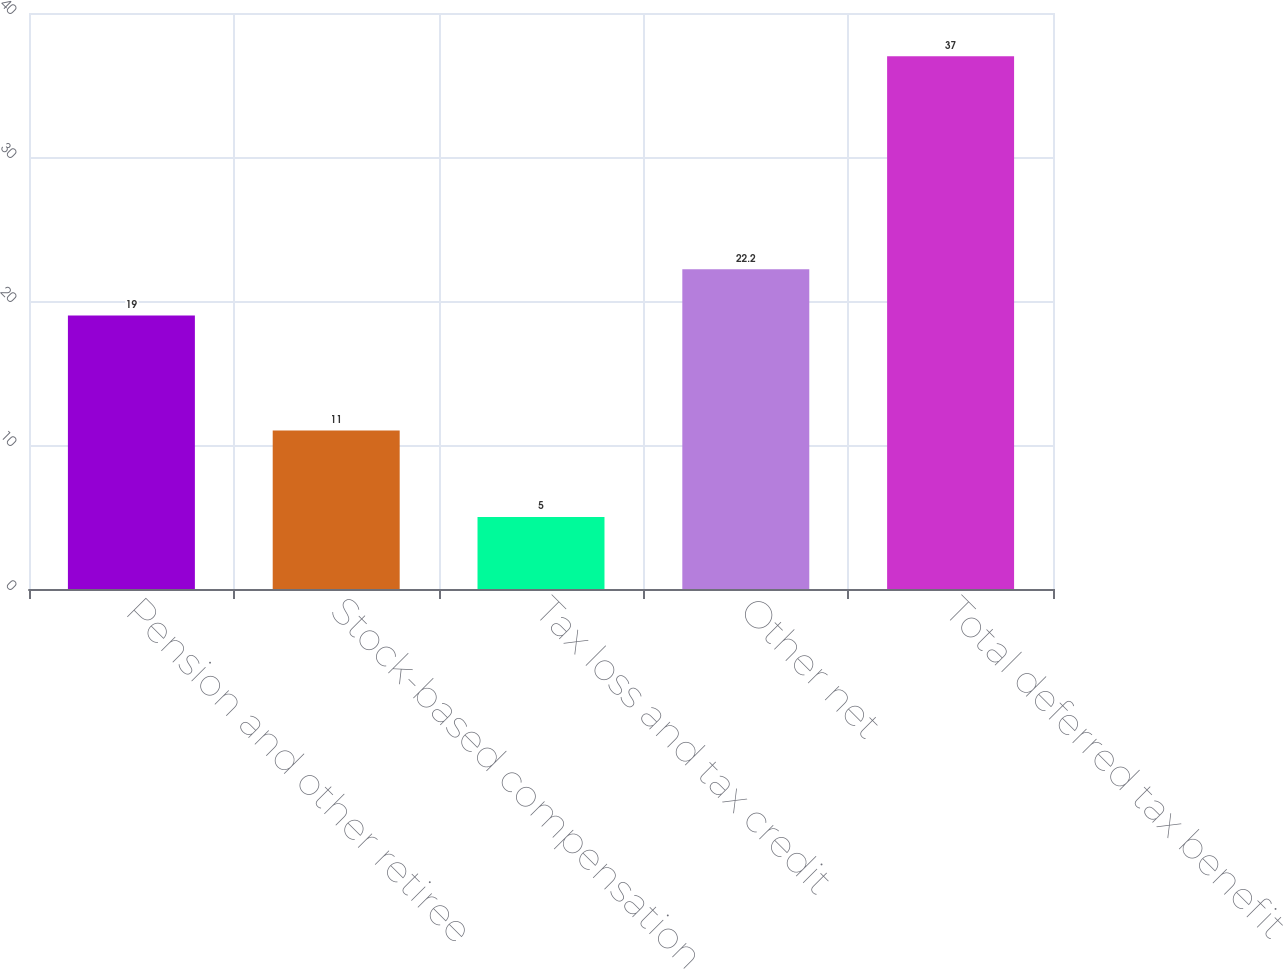Convert chart. <chart><loc_0><loc_0><loc_500><loc_500><bar_chart><fcel>Pension and other retiree<fcel>Stock-based compensation<fcel>Tax loss and tax credit<fcel>Other net<fcel>Total deferred tax benefit<nl><fcel>19<fcel>11<fcel>5<fcel>22.2<fcel>37<nl></chart> 